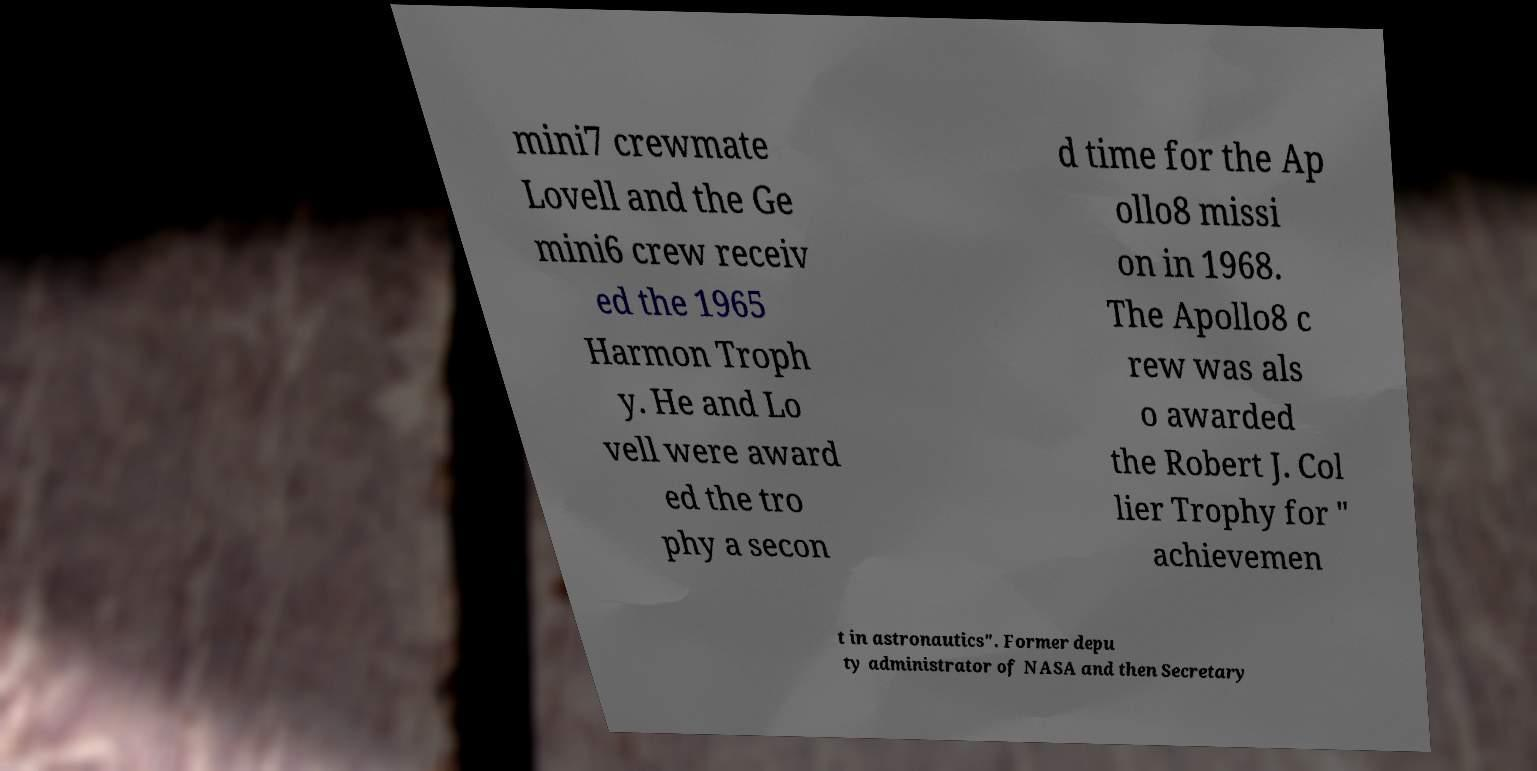Can you accurately transcribe the text from the provided image for me? mini7 crewmate Lovell and the Ge mini6 crew receiv ed the 1965 Harmon Troph y. He and Lo vell were award ed the tro phy a secon d time for the Ap ollo8 missi on in 1968. The Apollo8 c rew was als o awarded the Robert J. Col lier Trophy for " achievemen t in astronautics". Former depu ty administrator of NASA and then Secretary 